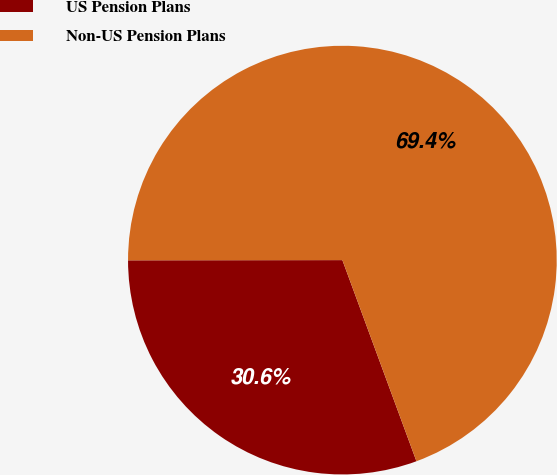<chart> <loc_0><loc_0><loc_500><loc_500><pie_chart><fcel>US Pension Plans<fcel>Non-US Pension Plans<nl><fcel>30.6%<fcel>69.4%<nl></chart> 